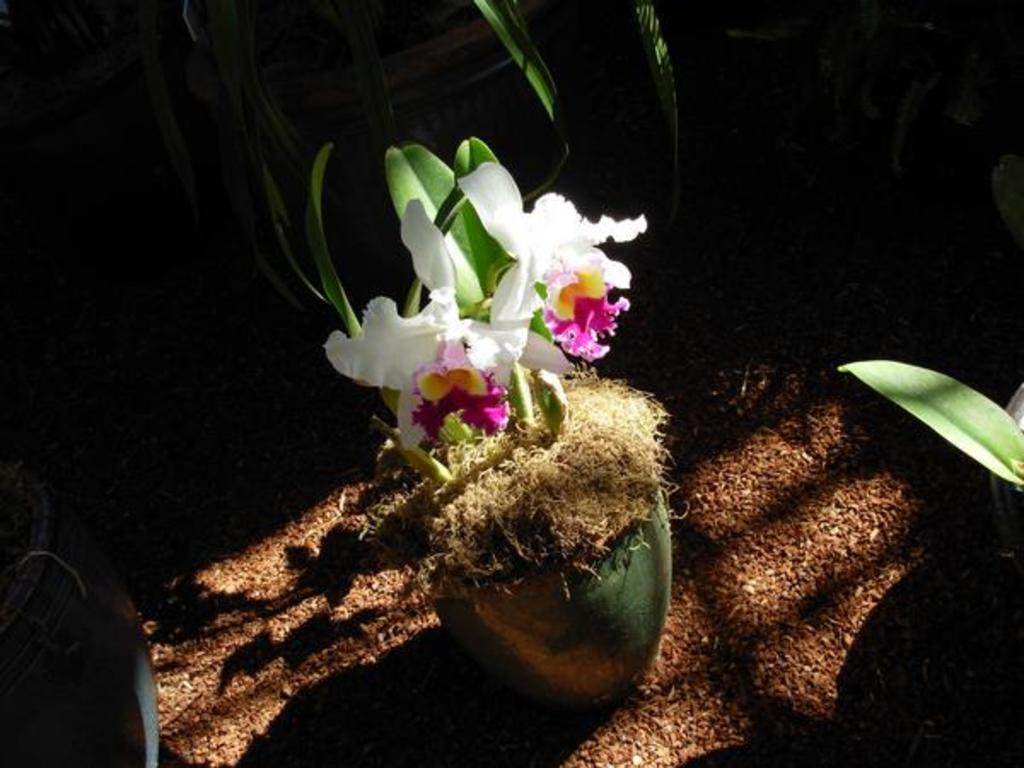In one or two sentences, can you explain what this image depicts? In this image we can see a plant with some flowers in a pot which is placed on the ground. We can also see some plants in the pots placed around it. 